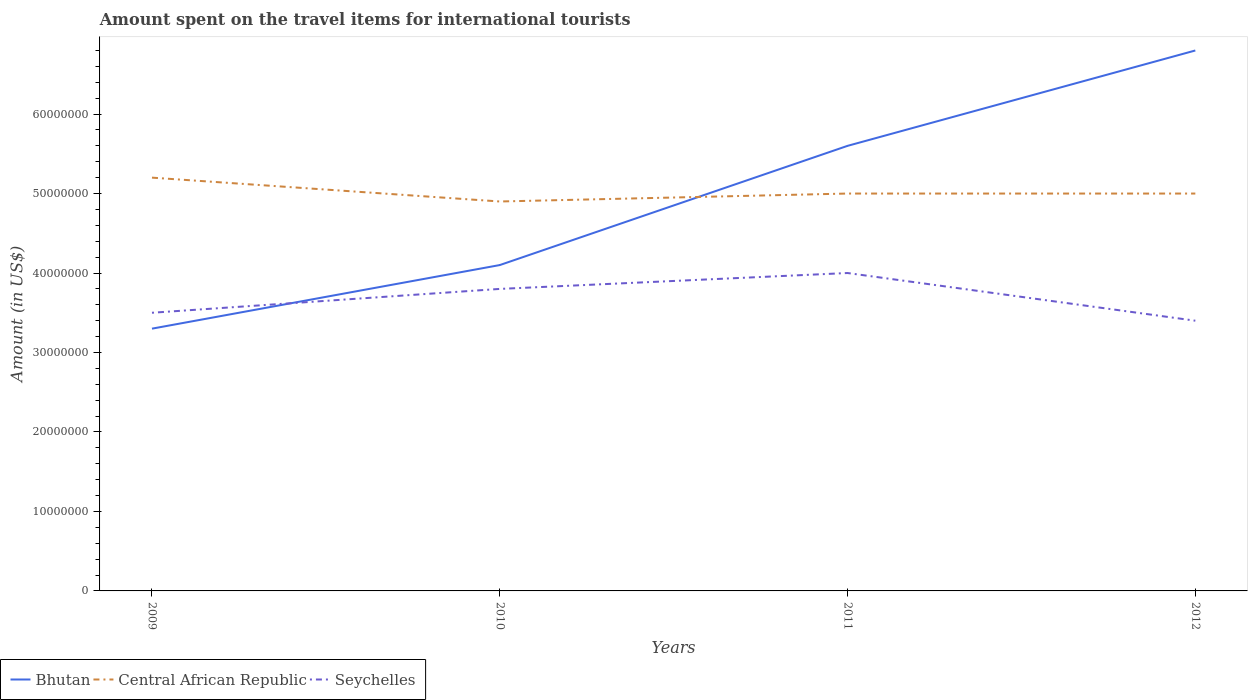Is the number of lines equal to the number of legend labels?
Provide a short and direct response. Yes. Across all years, what is the maximum amount spent on the travel items for international tourists in Seychelles?
Offer a terse response. 3.40e+07. In which year was the amount spent on the travel items for international tourists in Seychelles maximum?
Ensure brevity in your answer.  2012. What is the total amount spent on the travel items for international tourists in Central African Republic in the graph?
Your response must be concise. 3.00e+06. What is the difference between the highest and the second highest amount spent on the travel items for international tourists in Bhutan?
Provide a succinct answer. 3.50e+07. Is the amount spent on the travel items for international tourists in Bhutan strictly greater than the amount spent on the travel items for international tourists in Seychelles over the years?
Make the answer very short. No. How many years are there in the graph?
Give a very brief answer. 4. What is the difference between two consecutive major ticks on the Y-axis?
Give a very brief answer. 1.00e+07. Does the graph contain any zero values?
Your response must be concise. No. What is the title of the graph?
Offer a very short reply. Amount spent on the travel items for international tourists. Does "Marshall Islands" appear as one of the legend labels in the graph?
Keep it short and to the point. No. What is the label or title of the Y-axis?
Give a very brief answer. Amount (in US$). What is the Amount (in US$) in Bhutan in 2009?
Your answer should be compact. 3.30e+07. What is the Amount (in US$) in Central African Republic in 2009?
Make the answer very short. 5.20e+07. What is the Amount (in US$) in Seychelles in 2009?
Your answer should be very brief. 3.50e+07. What is the Amount (in US$) of Bhutan in 2010?
Your answer should be very brief. 4.10e+07. What is the Amount (in US$) in Central African Republic in 2010?
Offer a very short reply. 4.90e+07. What is the Amount (in US$) in Seychelles in 2010?
Ensure brevity in your answer.  3.80e+07. What is the Amount (in US$) in Bhutan in 2011?
Your answer should be compact. 5.60e+07. What is the Amount (in US$) of Central African Republic in 2011?
Give a very brief answer. 5.00e+07. What is the Amount (in US$) of Seychelles in 2011?
Make the answer very short. 4.00e+07. What is the Amount (in US$) in Bhutan in 2012?
Offer a terse response. 6.80e+07. What is the Amount (in US$) in Seychelles in 2012?
Provide a short and direct response. 3.40e+07. Across all years, what is the maximum Amount (in US$) of Bhutan?
Give a very brief answer. 6.80e+07. Across all years, what is the maximum Amount (in US$) of Central African Republic?
Offer a very short reply. 5.20e+07. Across all years, what is the maximum Amount (in US$) of Seychelles?
Offer a terse response. 4.00e+07. Across all years, what is the minimum Amount (in US$) of Bhutan?
Provide a short and direct response. 3.30e+07. Across all years, what is the minimum Amount (in US$) in Central African Republic?
Provide a short and direct response. 4.90e+07. Across all years, what is the minimum Amount (in US$) of Seychelles?
Your answer should be compact. 3.40e+07. What is the total Amount (in US$) of Bhutan in the graph?
Keep it short and to the point. 1.98e+08. What is the total Amount (in US$) in Central African Republic in the graph?
Ensure brevity in your answer.  2.01e+08. What is the total Amount (in US$) in Seychelles in the graph?
Offer a very short reply. 1.47e+08. What is the difference between the Amount (in US$) of Bhutan in 2009 and that in 2010?
Offer a very short reply. -8.00e+06. What is the difference between the Amount (in US$) of Central African Republic in 2009 and that in 2010?
Ensure brevity in your answer.  3.00e+06. What is the difference between the Amount (in US$) in Bhutan in 2009 and that in 2011?
Your answer should be compact. -2.30e+07. What is the difference between the Amount (in US$) in Seychelles in 2009 and that in 2011?
Your response must be concise. -5.00e+06. What is the difference between the Amount (in US$) of Bhutan in 2009 and that in 2012?
Ensure brevity in your answer.  -3.50e+07. What is the difference between the Amount (in US$) in Bhutan in 2010 and that in 2011?
Ensure brevity in your answer.  -1.50e+07. What is the difference between the Amount (in US$) of Central African Republic in 2010 and that in 2011?
Offer a terse response. -1.00e+06. What is the difference between the Amount (in US$) of Bhutan in 2010 and that in 2012?
Make the answer very short. -2.70e+07. What is the difference between the Amount (in US$) in Bhutan in 2011 and that in 2012?
Provide a short and direct response. -1.20e+07. What is the difference between the Amount (in US$) of Bhutan in 2009 and the Amount (in US$) of Central African Republic in 2010?
Ensure brevity in your answer.  -1.60e+07. What is the difference between the Amount (in US$) of Bhutan in 2009 and the Amount (in US$) of Seychelles in 2010?
Offer a very short reply. -5.00e+06. What is the difference between the Amount (in US$) in Central African Republic in 2009 and the Amount (in US$) in Seychelles in 2010?
Your response must be concise. 1.40e+07. What is the difference between the Amount (in US$) of Bhutan in 2009 and the Amount (in US$) of Central African Republic in 2011?
Your answer should be compact. -1.70e+07. What is the difference between the Amount (in US$) in Bhutan in 2009 and the Amount (in US$) in Seychelles in 2011?
Make the answer very short. -7.00e+06. What is the difference between the Amount (in US$) in Bhutan in 2009 and the Amount (in US$) in Central African Republic in 2012?
Your answer should be very brief. -1.70e+07. What is the difference between the Amount (in US$) of Bhutan in 2009 and the Amount (in US$) of Seychelles in 2012?
Ensure brevity in your answer.  -1.00e+06. What is the difference between the Amount (in US$) in Central African Republic in 2009 and the Amount (in US$) in Seychelles in 2012?
Your response must be concise. 1.80e+07. What is the difference between the Amount (in US$) in Bhutan in 2010 and the Amount (in US$) in Central African Republic in 2011?
Provide a short and direct response. -9.00e+06. What is the difference between the Amount (in US$) of Central African Republic in 2010 and the Amount (in US$) of Seychelles in 2011?
Your answer should be very brief. 9.00e+06. What is the difference between the Amount (in US$) in Bhutan in 2010 and the Amount (in US$) in Central African Republic in 2012?
Provide a short and direct response. -9.00e+06. What is the difference between the Amount (in US$) in Bhutan in 2010 and the Amount (in US$) in Seychelles in 2012?
Offer a very short reply. 7.00e+06. What is the difference between the Amount (in US$) of Central African Republic in 2010 and the Amount (in US$) of Seychelles in 2012?
Your answer should be compact. 1.50e+07. What is the difference between the Amount (in US$) in Bhutan in 2011 and the Amount (in US$) in Central African Republic in 2012?
Your response must be concise. 6.00e+06. What is the difference between the Amount (in US$) in Bhutan in 2011 and the Amount (in US$) in Seychelles in 2012?
Your response must be concise. 2.20e+07. What is the difference between the Amount (in US$) in Central African Republic in 2011 and the Amount (in US$) in Seychelles in 2012?
Give a very brief answer. 1.60e+07. What is the average Amount (in US$) of Bhutan per year?
Give a very brief answer. 4.95e+07. What is the average Amount (in US$) of Central African Republic per year?
Keep it short and to the point. 5.02e+07. What is the average Amount (in US$) of Seychelles per year?
Offer a very short reply. 3.68e+07. In the year 2009, what is the difference between the Amount (in US$) of Bhutan and Amount (in US$) of Central African Republic?
Keep it short and to the point. -1.90e+07. In the year 2009, what is the difference between the Amount (in US$) in Central African Republic and Amount (in US$) in Seychelles?
Provide a succinct answer. 1.70e+07. In the year 2010, what is the difference between the Amount (in US$) of Bhutan and Amount (in US$) of Central African Republic?
Make the answer very short. -8.00e+06. In the year 2010, what is the difference between the Amount (in US$) in Central African Republic and Amount (in US$) in Seychelles?
Keep it short and to the point. 1.10e+07. In the year 2011, what is the difference between the Amount (in US$) of Bhutan and Amount (in US$) of Central African Republic?
Offer a very short reply. 6.00e+06. In the year 2011, what is the difference between the Amount (in US$) in Bhutan and Amount (in US$) in Seychelles?
Make the answer very short. 1.60e+07. In the year 2011, what is the difference between the Amount (in US$) of Central African Republic and Amount (in US$) of Seychelles?
Provide a succinct answer. 1.00e+07. In the year 2012, what is the difference between the Amount (in US$) of Bhutan and Amount (in US$) of Central African Republic?
Give a very brief answer. 1.80e+07. In the year 2012, what is the difference between the Amount (in US$) in Bhutan and Amount (in US$) in Seychelles?
Your response must be concise. 3.40e+07. In the year 2012, what is the difference between the Amount (in US$) in Central African Republic and Amount (in US$) in Seychelles?
Provide a short and direct response. 1.60e+07. What is the ratio of the Amount (in US$) of Bhutan in 2009 to that in 2010?
Ensure brevity in your answer.  0.8. What is the ratio of the Amount (in US$) in Central African Republic in 2009 to that in 2010?
Your answer should be very brief. 1.06. What is the ratio of the Amount (in US$) in Seychelles in 2009 to that in 2010?
Your response must be concise. 0.92. What is the ratio of the Amount (in US$) in Bhutan in 2009 to that in 2011?
Your answer should be compact. 0.59. What is the ratio of the Amount (in US$) in Bhutan in 2009 to that in 2012?
Keep it short and to the point. 0.49. What is the ratio of the Amount (in US$) in Seychelles in 2009 to that in 2012?
Ensure brevity in your answer.  1.03. What is the ratio of the Amount (in US$) in Bhutan in 2010 to that in 2011?
Keep it short and to the point. 0.73. What is the ratio of the Amount (in US$) of Central African Republic in 2010 to that in 2011?
Your answer should be compact. 0.98. What is the ratio of the Amount (in US$) in Seychelles in 2010 to that in 2011?
Your answer should be very brief. 0.95. What is the ratio of the Amount (in US$) in Bhutan in 2010 to that in 2012?
Your answer should be very brief. 0.6. What is the ratio of the Amount (in US$) in Seychelles in 2010 to that in 2012?
Your answer should be very brief. 1.12. What is the ratio of the Amount (in US$) of Bhutan in 2011 to that in 2012?
Your answer should be compact. 0.82. What is the ratio of the Amount (in US$) in Central African Republic in 2011 to that in 2012?
Ensure brevity in your answer.  1. What is the ratio of the Amount (in US$) of Seychelles in 2011 to that in 2012?
Offer a very short reply. 1.18. What is the difference between the highest and the second highest Amount (in US$) in Bhutan?
Your answer should be very brief. 1.20e+07. What is the difference between the highest and the lowest Amount (in US$) of Bhutan?
Give a very brief answer. 3.50e+07. What is the difference between the highest and the lowest Amount (in US$) of Seychelles?
Offer a terse response. 6.00e+06. 